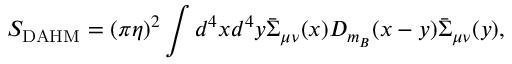Convert formula to latex. <formula><loc_0><loc_0><loc_500><loc_500>S _ { D A H M } = ( \pi \eta ) ^ { 2 } \int d ^ { 4 } x d ^ { 4 } y \bar { \Sigma } _ { \mu \nu } ( x ) D _ { m _ { B } } ( x - y ) \bar { \Sigma } _ { \mu \nu } ( y ) ,</formula> 